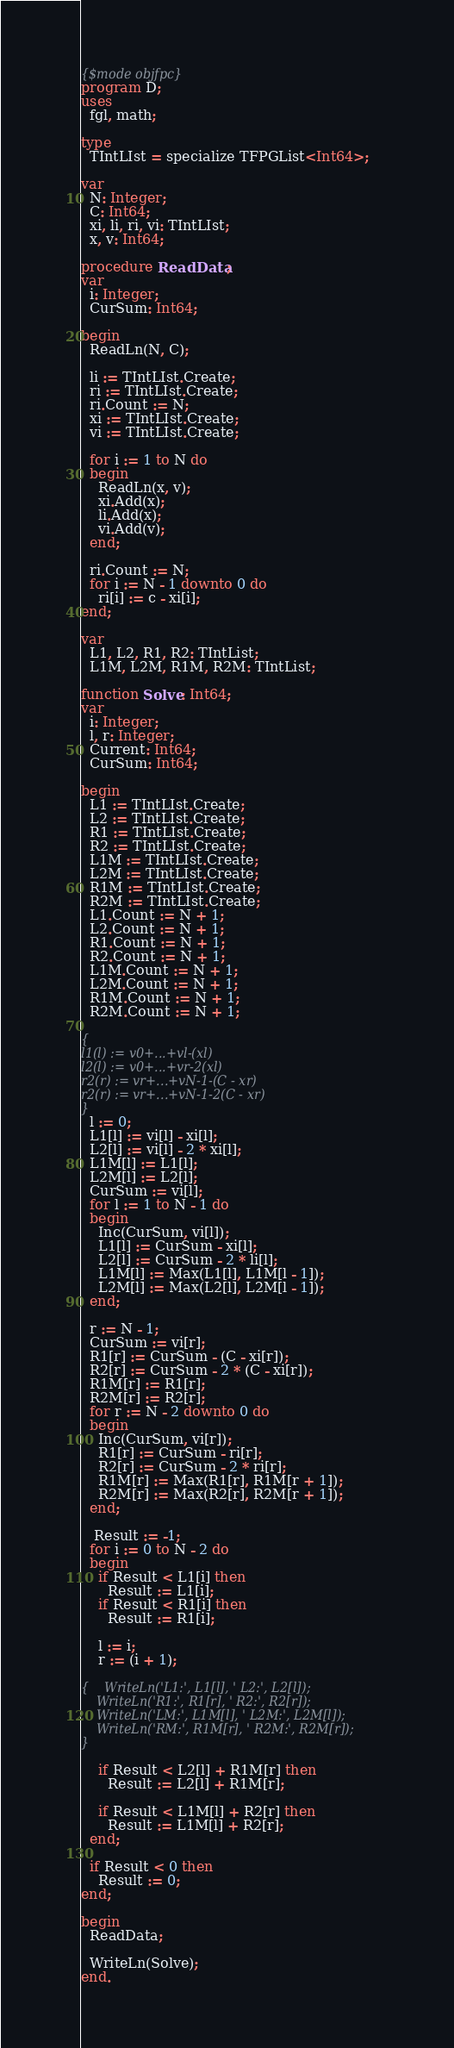<code> <loc_0><loc_0><loc_500><loc_500><_Pascal_>{$mode objfpc}
program D;
uses
  fgl, math;

type
  TIntLIst = specialize TFPGList<Int64>;

var
  N: Integer;
  C: Int64;
  xi, li, ri, vi: TIntLIst;
  x, v: Int64;

procedure ReadData;
var
  i: Integer;
  CurSum: Int64;

begin
  ReadLn(N, C);

  li := TIntLIst.Create;
  ri := TIntLIst.Create;
  ri.Count := N;
  xi := TIntLIst.Create;
  vi := TIntLIst.Create;

  for i := 1 to N do
  begin
    ReadLn(x, v);
    xi.Add(x);
    li.Add(x);
    vi.Add(v);
  end;

  ri.Count := N;
  for i := N - 1 downto 0 do
    ri[i] := c - xi[i];
end;

var
  L1, L2, R1, R2: TIntList;
  L1M, L2M, R1M, R2M: TIntList;

function Solve: Int64;
var
  i: Integer;
  l, r: Integer;
  Current: Int64;
  CurSum: Int64;

begin
  L1 := TIntLIst.Create;
  L2 := TIntLIst.Create;
  R1 := TIntLIst.Create;
  R2 := TIntLIst.Create;
  L1M := TIntLIst.Create;
  L2M := TIntLIst.Create;
  R1M := TIntLIst.Create;
  R2M := TIntLIst.Create;
  L1.Count := N + 1;
  L2.Count := N + 1;
  R1.Count := N + 1;
  R2.Count := N + 1;
  L1M.Count := N + 1;
  L2M.Count := N + 1;
  R1M.Count := N + 1;
  R2M.Count := N + 1;

{
l1(l) := v0+...+vl-(xl)
l2(l) := v0+...+vr-2(xl)
r2(r) := vr+...+vN-1-(C - xr)
r2(r) := vr+...+vN-1-2(C - xr)
}
  l := 0;
  L1[l] := vi[l] - xi[l];
  L2[l] := vi[l] - 2 * xi[l];
  L1M[l] := L1[l];
  L2M[l] := L2[l];
  CurSum := vi[l];
  for l := 1 to N - 1 do
  begin
    Inc(CurSum, vi[l]);
    L1[l] := CurSum - xi[l];
    L2[l] := CurSum - 2 * li[l];
    L1M[l] := Max(L1[l], L1M[l - 1]);
    L2M[l] := Max(L2[l], L2M[l - 1]);
  end;

  r := N - 1;
  CurSum := vi[r];
  R1[r] := CurSum - (C - xi[r]);
  R2[r] := CurSum - 2 * (C - xi[r]);
  R1M[r] := R1[r];
  R2M[r] := R2[r];
  for r := N - 2 downto 0 do
  begin
    Inc(CurSum, vi[r]);
    R1[r] := CurSum - ri[r];
    R2[r] := CurSum - 2 * ri[r];
    R1M[r] := Max(R1[r], R1M[r + 1]);
    R2M[r] := Max(R2[r], R2M[r + 1]);
  end;

   Result := -1;
  for i := 0 to N - 2 do
  begin
    if Result < L1[i] then
      Result := L1[i];
    if Result < R1[i] then
      Result := R1[i];

    l := i;
    r := (i + 1);

{    WriteLn('L1:', L1[l], ' L2:', L2[l]); 
    WriteLn('R1:', R1[r], ' R2:', R2[r]); 
    WriteLn('LM:', L1M[l], ' L2M:', L2M[l]); 
    WriteLn('RM:', R1M[r], ' R2M:', R2M[r]); 
}

    if Result < L2[l] + R1M[r] then
      Result := L2[l] + R1M[r];

    if Result < L1M[l] + R2[r] then
      Result := L1M[l] + R2[r];
  end;
 
  if Result < 0 then
    Result := 0;
end;

begin
  ReadData;

  WriteLn(Solve);
end.</code> 